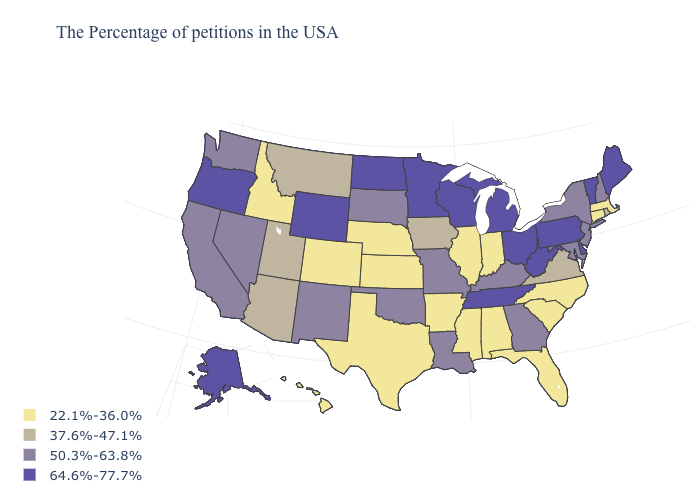Among the states that border Montana , does Idaho have the highest value?
Answer briefly. No. What is the value of Delaware?
Quick response, please. 64.6%-77.7%. Name the states that have a value in the range 50.3%-63.8%?
Answer briefly. New Hampshire, New York, New Jersey, Maryland, Georgia, Kentucky, Louisiana, Missouri, Oklahoma, South Dakota, New Mexico, Nevada, California, Washington. Among the states that border Idaho , does Wyoming have the highest value?
Answer briefly. Yes. Name the states that have a value in the range 37.6%-47.1%?
Quick response, please. Rhode Island, Virginia, Iowa, Utah, Montana, Arizona. Does Mississippi have the lowest value in the South?
Be succinct. Yes. What is the value of Delaware?
Keep it brief. 64.6%-77.7%. What is the value of Missouri?
Quick response, please. 50.3%-63.8%. Name the states that have a value in the range 64.6%-77.7%?
Write a very short answer. Maine, Vermont, Delaware, Pennsylvania, West Virginia, Ohio, Michigan, Tennessee, Wisconsin, Minnesota, North Dakota, Wyoming, Oregon, Alaska. Does Louisiana have the same value as New Mexico?
Answer briefly. Yes. What is the value of South Carolina?
Answer briefly. 22.1%-36.0%. Which states have the lowest value in the USA?
Write a very short answer. Massachusetts, Connecticut, North Carolina, South Carolina, Florida, Indiana, Alabama, Illinois, Mississippi, Arkansas, Kansas, Nebraska, Texas, Colorado, Idaho, Hawaii. Does Texas have a lower value than Illinois?
Concise answer only. No. Does Massachusetts have the lowest value in the Northeast?
Give a very brief answer. Yes. Does Missouri have a higher value than Indiana?
Write a very short answer. Yes. 